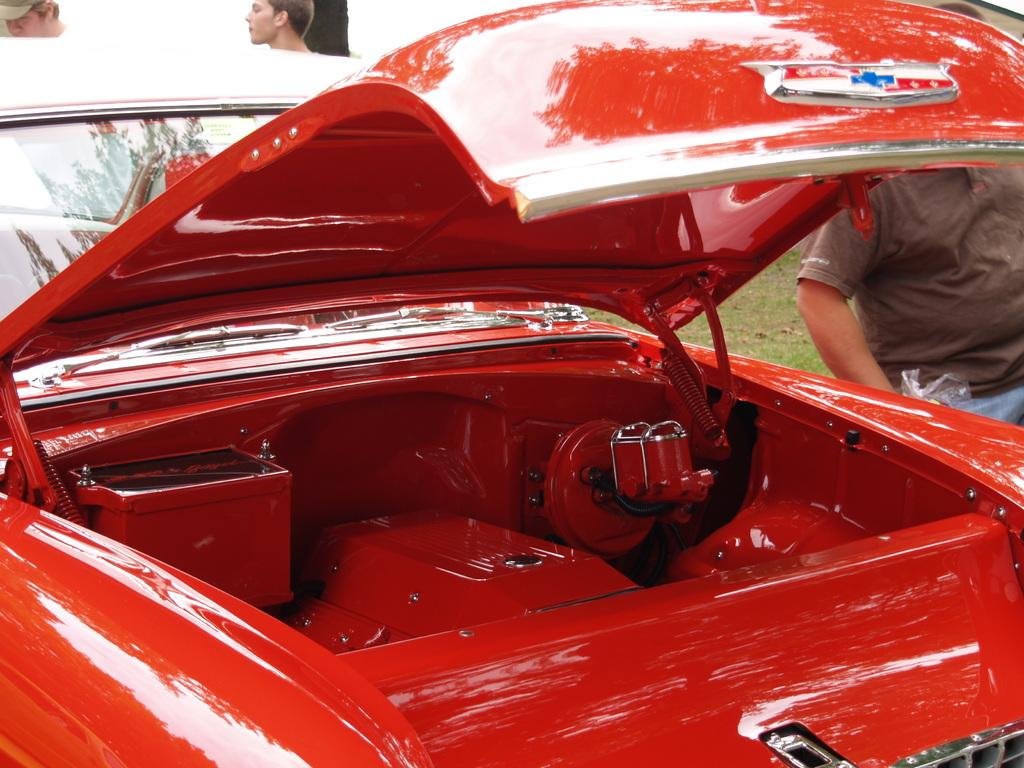What color is the car in the image? The car in the image is red. How many people are behind the car? There are three persons behind the car. What type of vegetation can be seen in the image? There is grass visible in the image. What type of dinner is being served to the yak in the image? There is no yak or dinner present in the image. 